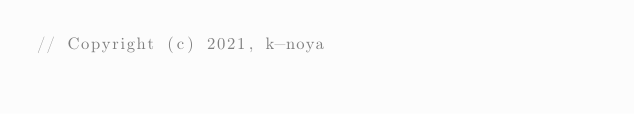<code> <loc_0><loc_0><loc_500><loc_500><_C++_>// Copyright (c) 2021, k-noya</code> 